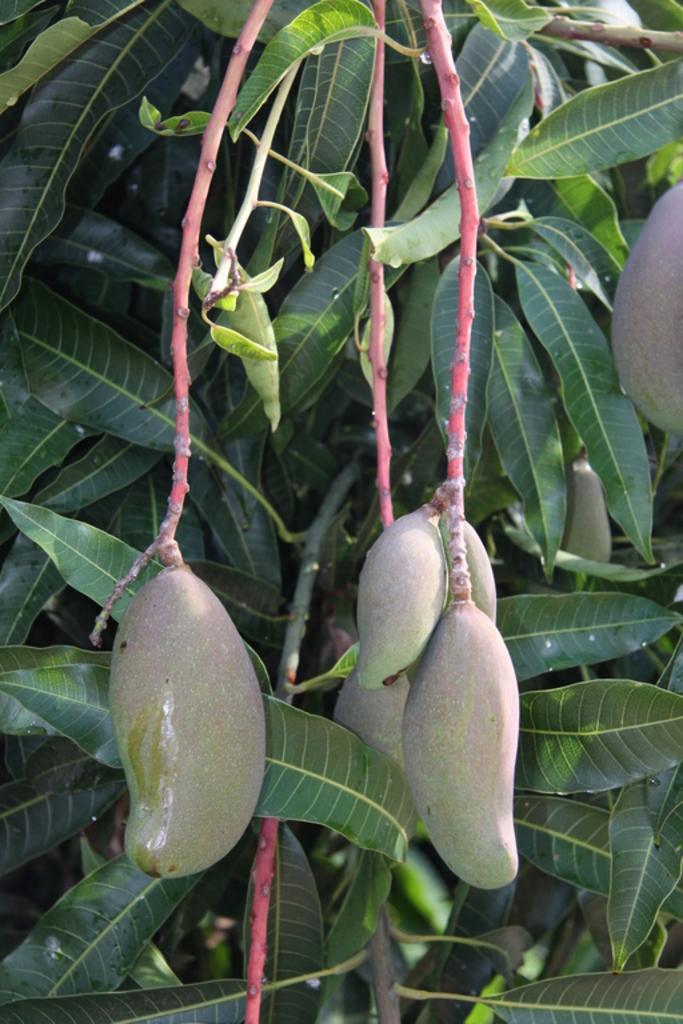How would you summarize this image in a sentence or two? In this picture there are few mangoes and there are mango leaves behind it. 